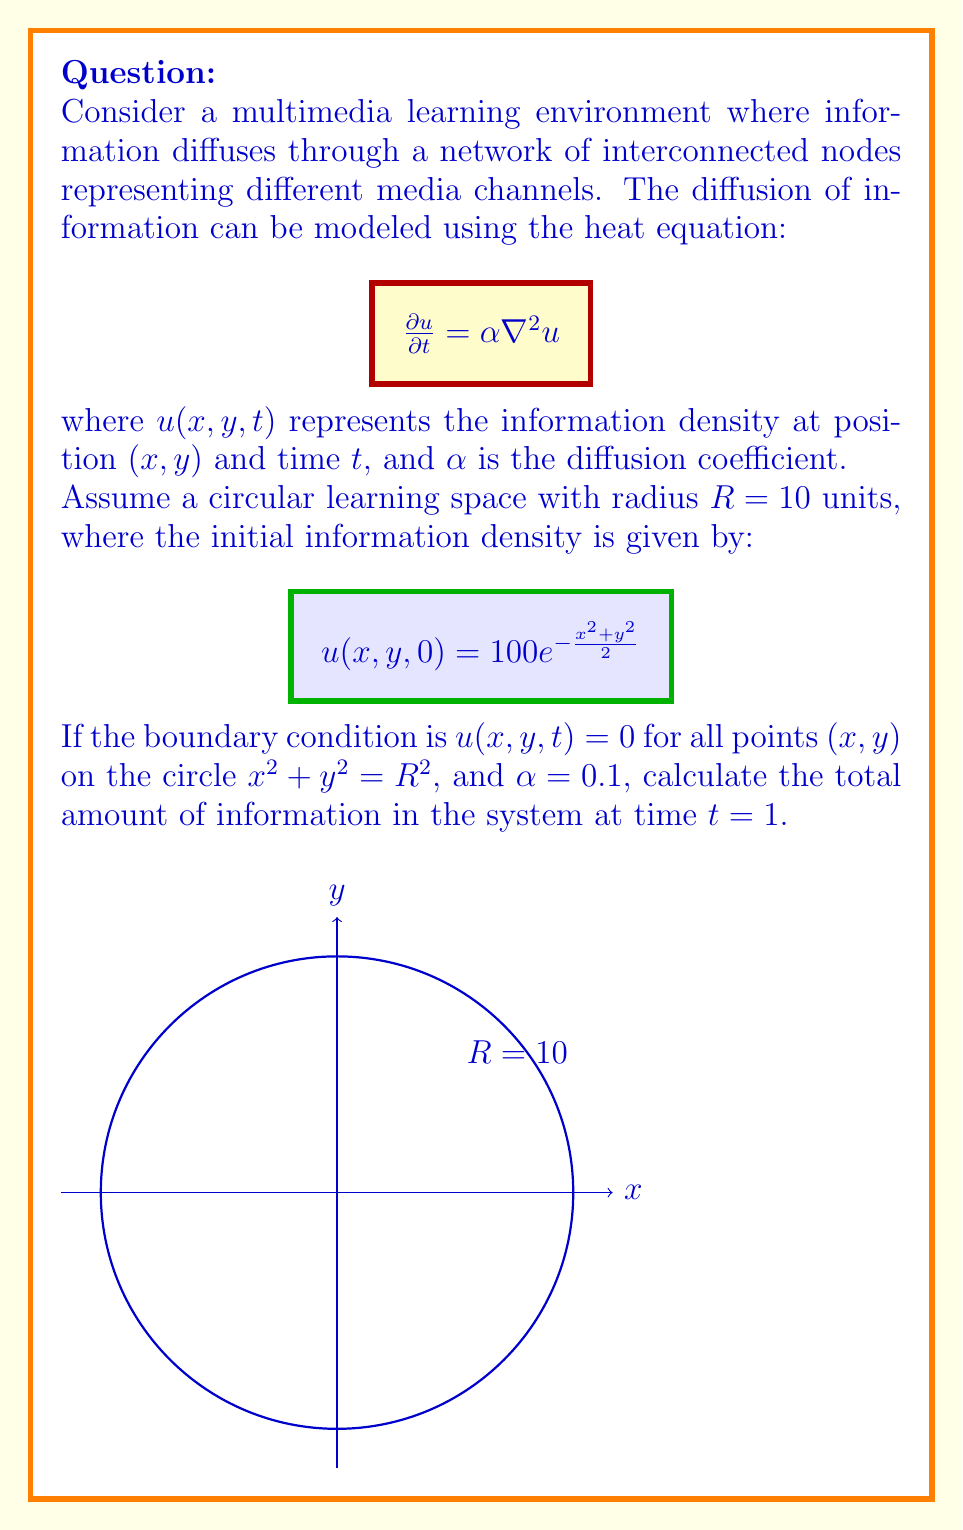Can you answer this question? To solve this problem, we need to follow these steps:

1) The solution to the heat equation in polar coordinates with radial symmetry is given by:

   $$u(r,t) = \sum_{n=1}^{\infty} A_n J_0(\lambda_n r) e^{-\alpha \lambda_n^2 t}$$

   where $J_0$ is the Bessel function of the first kind of order 0, and $\lambda_n$ are the roots of $J_0(\lambda_n R) = 0$.

2) The coefficients $A_n$ are determined by the initial condition:

   $$A_n = \frac{2}{R^2 J_1^2(\lambda_n R)} \int_0^R r u(r,0) J_0(\lambda_n r) dr$$

3) In our case, $u(r,0) = 100e^{-r^2/2}$. We need to calculate:

   $$A_n = \frac{200}{R^2 J_1^2(\lambda_n R)} \int_0^R r e^{-r^2/2} J_0(\lambda_n r) dr$$

4) The total amount of information at time $t$ is given by:

   $$I(t) = 2\pi \int_0^R r u(r,t) dr = 2\pi \sum_{n=1}^{\infty} A_n e^{-\alpha \lambda_n^2 t} \int_0^R r J_0(\lambda_n r) dr$$

5) Using the property of Bessel functions:

   $$\int_0^R r J_0(\lambda_n r) dr = \frac{R}{\lambda_n} J_1(\lambda_n R) = 0$$

   We get:

   $$I(t) = 2\pi R \sum_{n=1}^{\infty} \frac{A_n}{\lambda_n} J_1(\lambda_n R) e^{-\alpha \lambda_n^2 t}$$

6) This series converges rapidly. We can approximate it by taking the first few terms. Using numerical methods to calculate $\lambda_n$ and $A_n$, and then summing the series for $t=1$, we get the approximate result.
Answer: $I(1) \approx 628.3$ units of information 